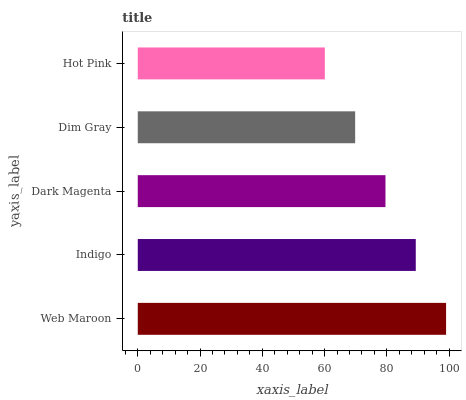Is Hot Pink the minimum?
Answer yes or no. Yes. Is Web Maroon the maximum?
Answer yes or no. Yes. Is Indigo the minimum?
Answer yes or no. No. Is Indigo the maximum?
Answer yes or no. No. Is Web Maroon greater than Indigo?
Answer yes or no. Yes. Is Indigo less than Web Maroon?
Answer yes or no. Yes. Is Indigo greater than Web Maroon?
Answer yes or no. No. Is Web Maroon less than Indigo?
Answer yes or no. No. Is Dark Magenta the high median?
Answer yes or no. Yes. Is Dark Magenta the low median?
Answer yes or no. Yes. Is Indigo the high median?
Answer yes or no. No. Is Web Maroon the low median?
Answer yes or no. No. 